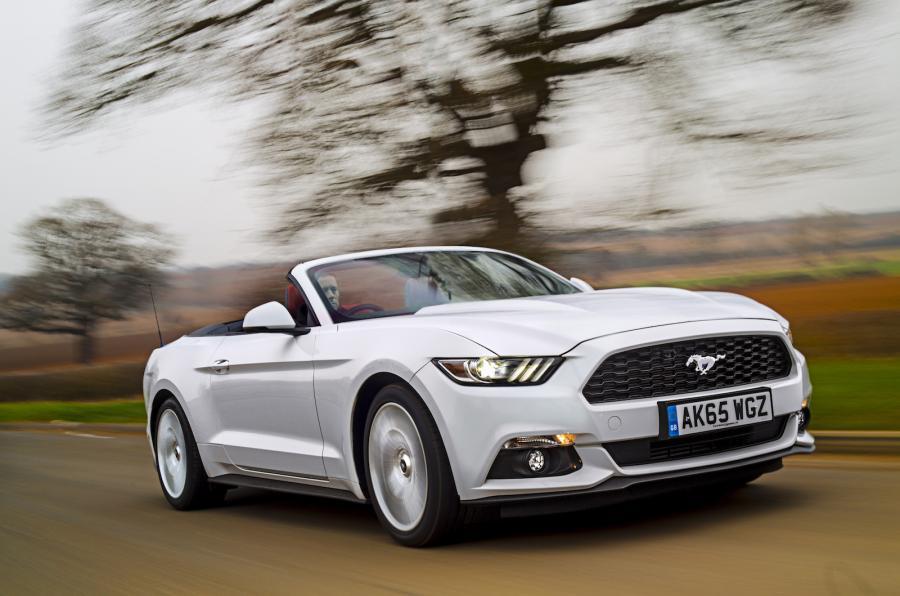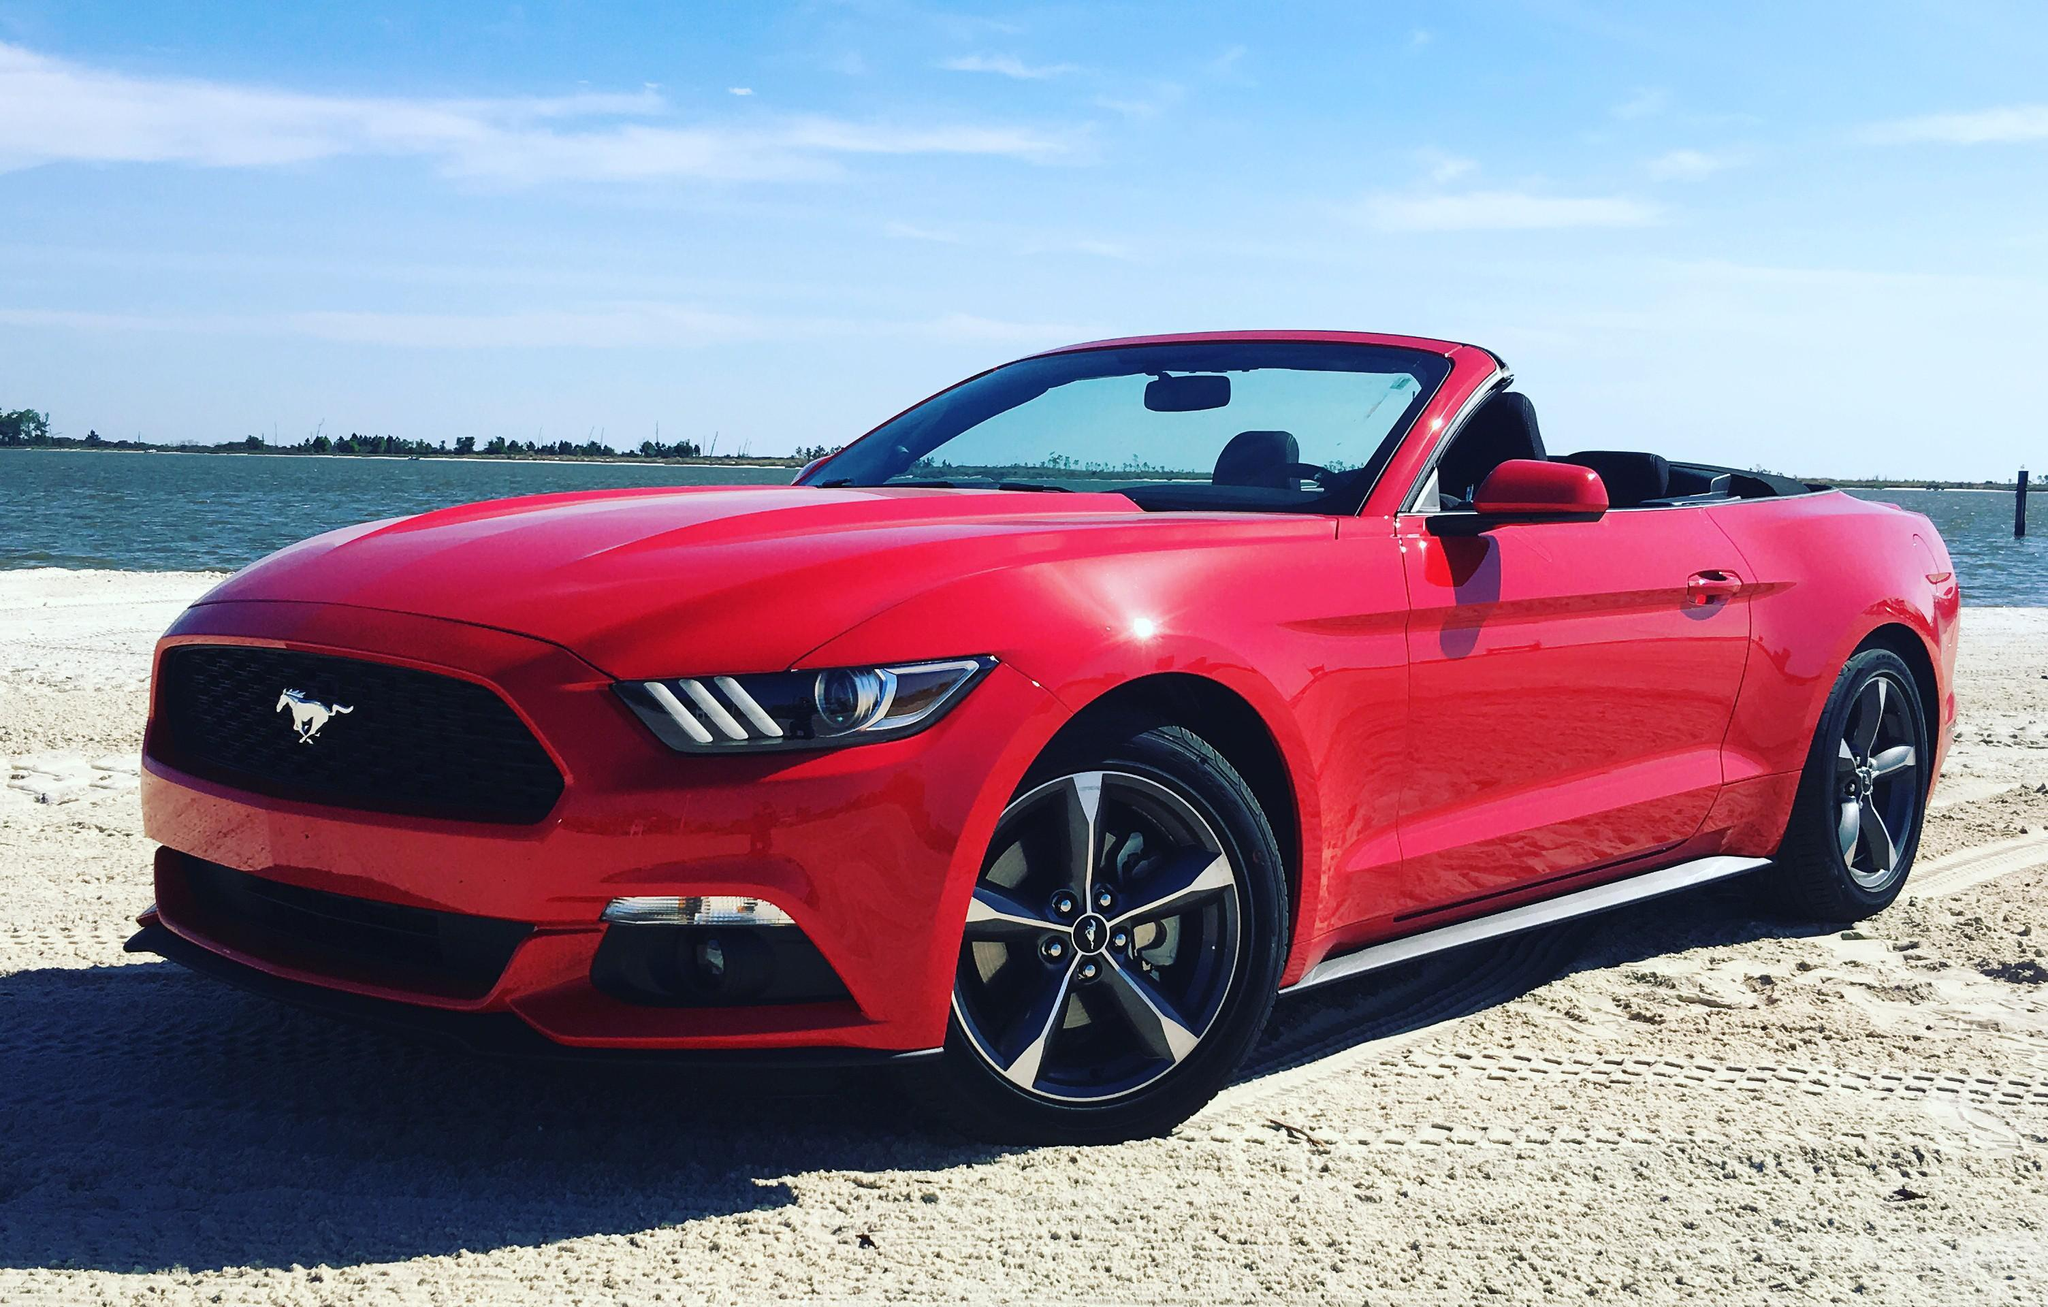The first image is the image on the left, the second image is the image on the right. Assess this claim about the two images: "a convertible mustang is parked on a sandy beach". Correct or not? Answer yes or no. Yes. The first image is the image on the left, the second image is the image on the right. Assess this claim about the two images: "One Ford Mustang is parked in dirt.". Correct or not? Answer yes or no. Yes. 